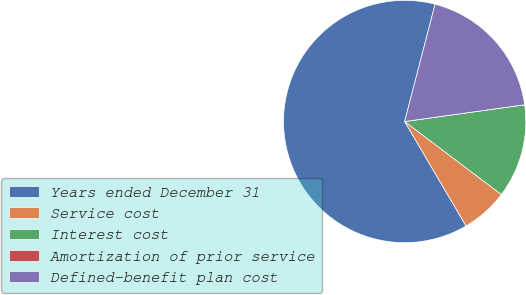<chart> <loc_0><loc_0><loc_500><loc_500><pie_chart><fcel>Years ended December 31<fcel>Service cost<fcel>Interest cost<fcel>Amortization of prior service<fcel>Defined-benefit plan cost<nl><fcel>62.49%<fcel>6.25%<fcel>12.5%<fcel>0.0%<fcel>18.75%<nl></chart> 